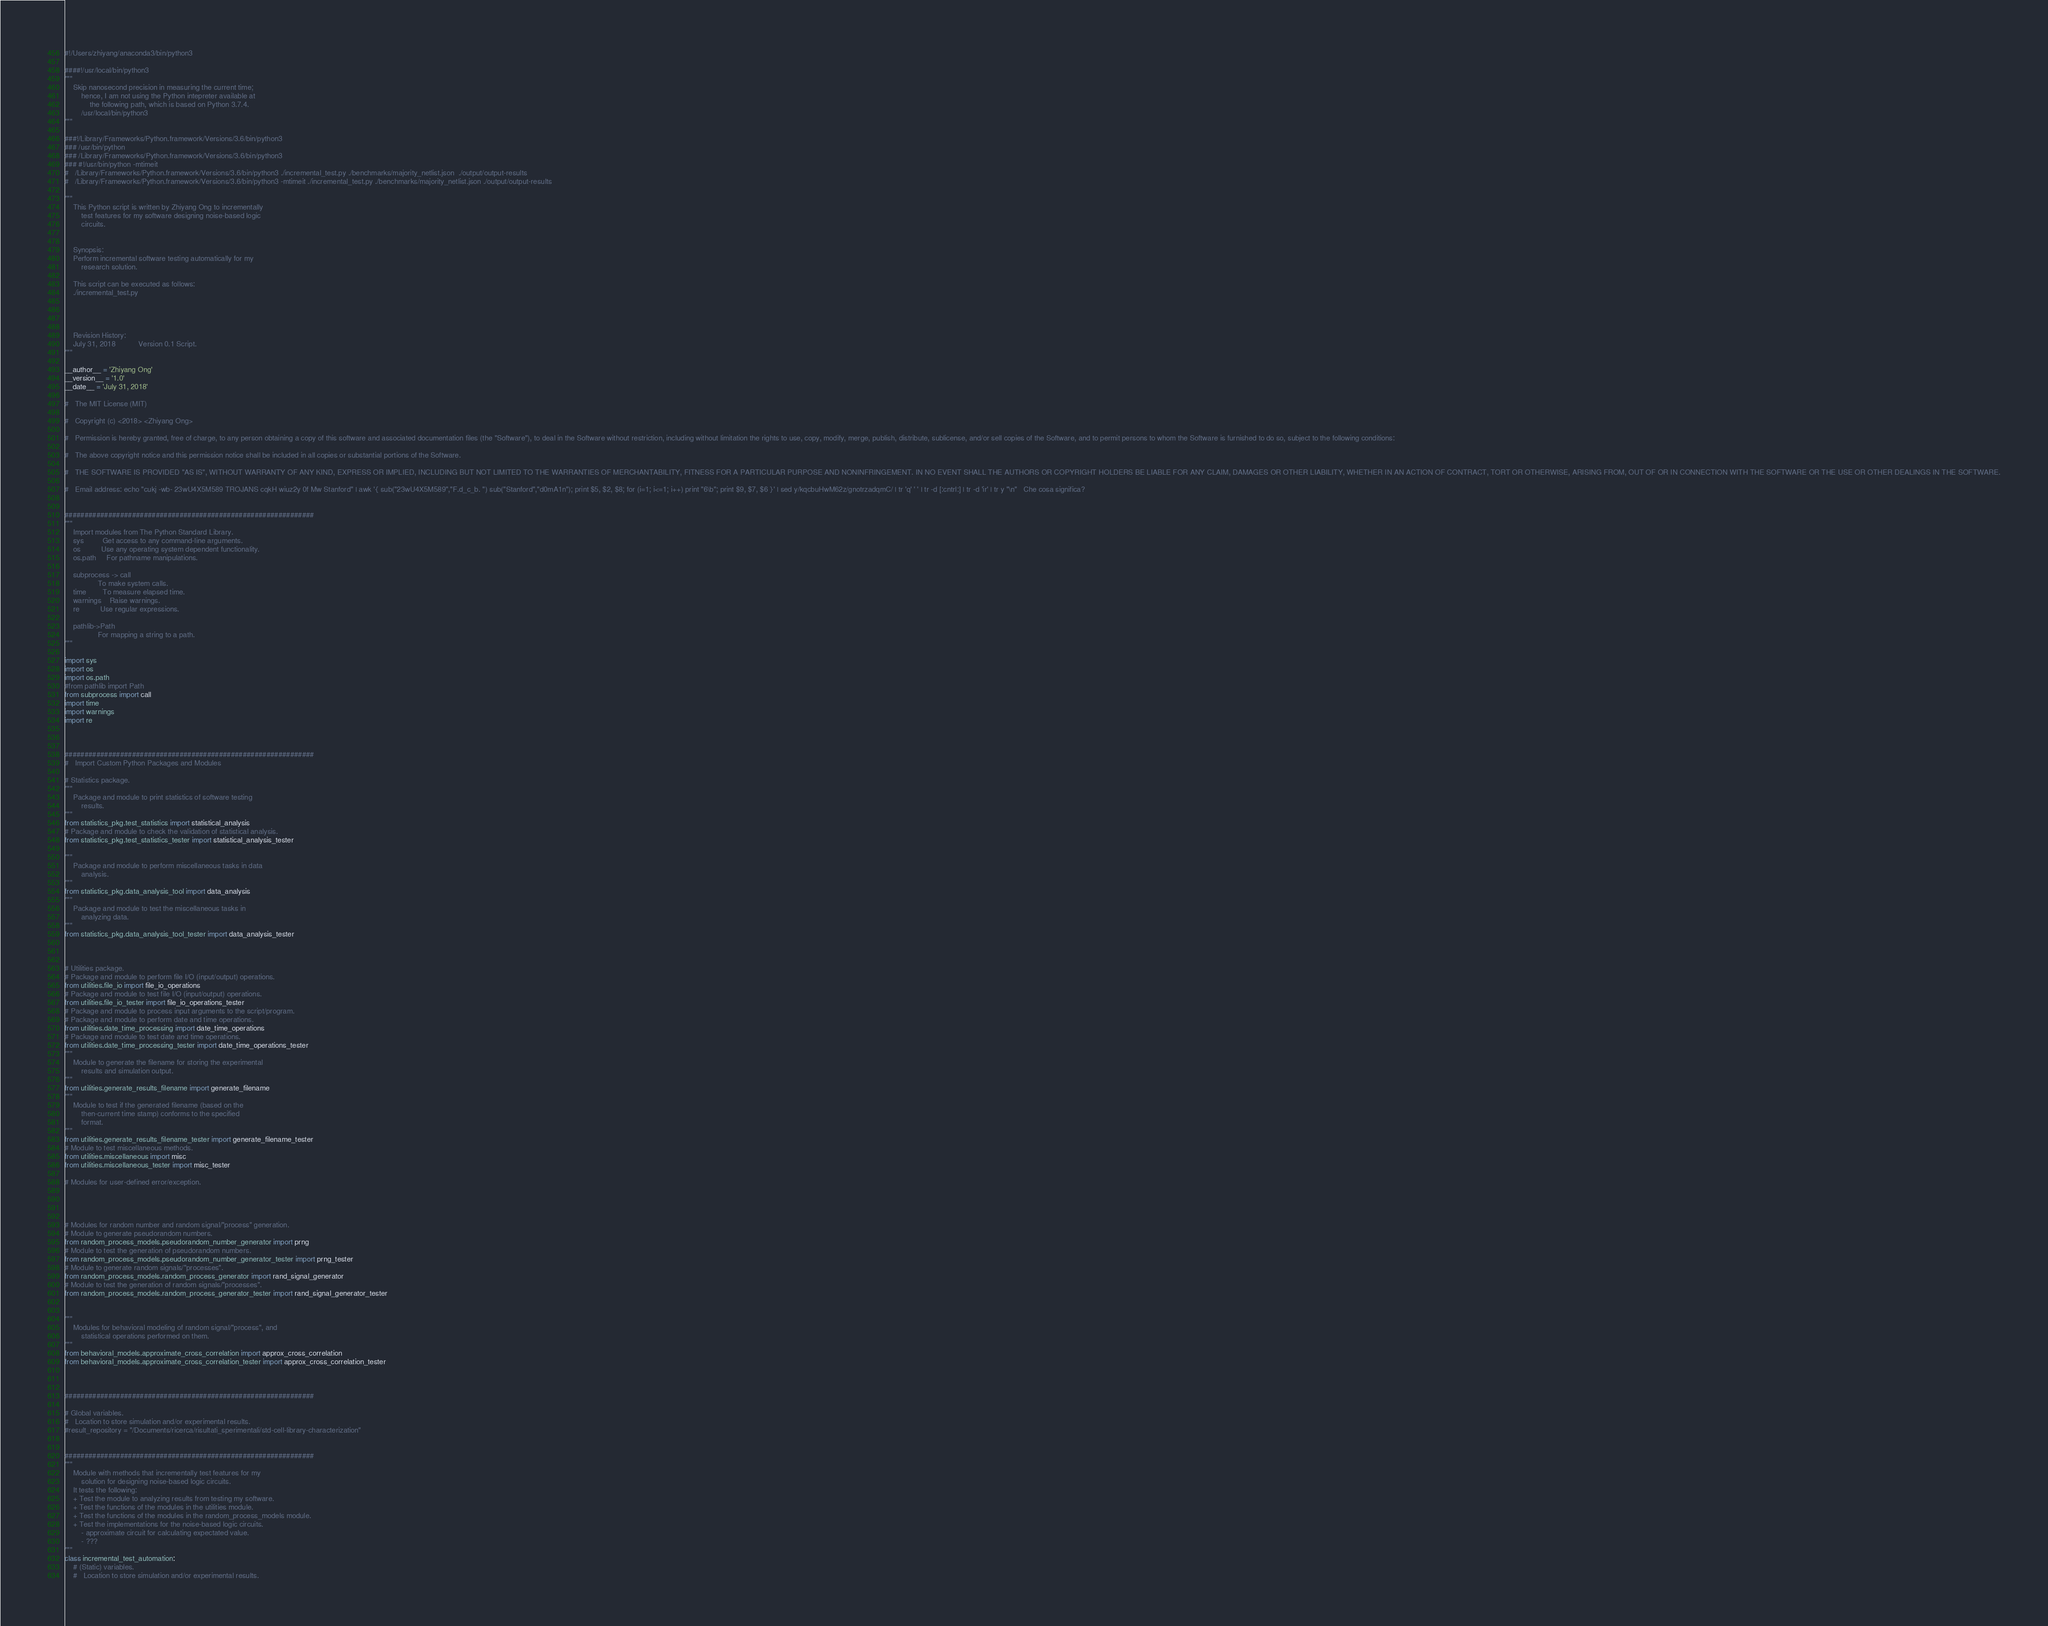Convert code to text. <code><loc_0><loc_0><loc_500><loc_500><_Python_>#!/Users/zhiyang/anaconda3/bin/python3 

####!/usr/local/bin/python3
"""
	Skip nanosecond precision in measuring the current time;
		hence, I am not using the Python intepreter available at
			the following path, which is based on Python 3.7.4.
		/usr/local/bin/python3
"""

###!/Library/Frameworks/Python.framework/Versions/3.6/bin/python3
###	/usr/bin/python
###	/Library/Frameworks/Python.framework/Versions/3.6/bin/python3
###	#!/usr/bin/python -mtimeit
#	/Library/Frameworks/Python.framework/Versions/3.6/bin/python3 ./incremental_test.py ./benchmarks/majority_netlist.json	./output/output-results
#	/Library/Frameworks/Python.framework/Versions/3.6/bin/python3 -mtimeit ./incremental_test.py ./benchmarks/majority_netlist.json	./output/output-results

"""
	This Python script is written by Zhiyang Ong to incrementally
		test features for my software designing noise-based logic
		circuits.


	Synopsis:
	Perform incremental software testing automatically for my
		research solution.

	This script can be executed as follows:
	./incremental_test.py




	Revision History:
	July 31, 2018			Version 0.1	Script.
"""

__author__ = 'Zhiyang Ong'
__version__ = '1.0'
__date__ = 'July 31, 2018'

#	The MIT License (MIT)

#	Copyright (c) <2018> <Zhiyang Ong>

#	Permission is hereby granted, free of charge, to any person obtaining a copy of this software and associated documentation files (the "Software"), to deal in the Software without restriction, including without limitation the rights to use, copy, modify, merge, publish, distribute, sublicense, and/or sell copies of the Software, and to permit persons to whom the Software is furnished to do so, subject to the following conditions:

#	The above copyright notice and this permission notice shall be included in all copies or substantial portions of the Software.

#	THE SOFTWARE IS PROVIDED "AS IS", WITHOUT WARRANTY OF ANY KIND, EXPRESS OR IMPLIED, INCLUDING BUT NOT LIMITED TO THE WARRANTIES OF MERCHANTABILITY, FITNESS FOR A PARTICULAR PURPOSE AND NONINFRINGEMENT. IN NO EVENT SHALL THE AUTHORS OR COPYRIGHT HOLDERS BE LIABLE FOR ANY CLAIM, DAMAGES OR OTHER LIABILITY, WHETHER IN AN ACTION OF CONTRACT, TORT OR OTHERWISE, ARISING FROM, OUT OF OR IN CONNECTION WITH THE SOFTWARE OR THE USE OR OTHER DEALINGS IN THE SOFTWARE.

#	Email address: echo "cukj -wb- 23wU4X5M589 TROJANS cqkH wiuz2y 0f Mw Stanford" | awk '{ sub("23wU4X5M589","F.d_c_b. ") sub("Stanford","d0mA1n"); print $5, $2, $8; for (i=1; i<=1; i++) print "6\b"; print $9, $7, $6 }' | sed y/kqcbuHwM62z/gnotrzadqmC/ | tr 'q' ' ' | tr -d [:cntrl:] | tr -d 'ir' | tr y "\n"	Che cosa significa?


###############################################################
"""
	Import modules from The Python Standard Library.
	sys			Get access to any command-line arguments.
	os			Use any operating system dependent functionality.
	os.path		For pathname manipulations.

	subprocess -> call
				To make system calls.
	time		To measure elapsed time.
	warnings	Raise warnings.
	re			Use regular expressions.

	pathlib->Path
				For mapping a string to a path.
"""

import sys
import os
import os.path
#from pathlib import Path
from subprocess import call
import time
import warnings
import re



###############################################################
#	Import Custom Python Packages and Modules

# Statistics package.
"""
	Package and module to print statistics of software testing
		results.
"""
from statistics_pkg.test_statistics import statistical_analysis
# Package and module to check the validation of statistical analysis.
from statistics_pkg.test_statistics_tester import statistical_analysis_tester

"""
	Package and module to perform miscellaneous tasks in data
		analysis.
"""
from statistics_pkg.data_analysis_tool import data_analysis
"""
	Package and module to test the miscellaneous tasks in
		analyzing data. 
"""
from statistics_pkg.data_analysis_tool_tester import data_analysis_tester



# Utilities package.
# Package and module to perform file I/O (input/output) operations.
from utilities.file_io import file_io_operations
# Package and module to test file I/O (input/output) operations.
from utilities.file_io_tester import file_io_operations_tester
# Package and module to process input arguments to the script/program.
# Package and module to perform date and time operations.
from utilities.date_time_processing import date_time_operations
# Package and module to test date and time operations.
from utilities.date_time_processing_tester import date_time_operations_tester
"""
	Module to generate the filename for storing the experimental
		results and simulation output.
"""
from utilities.generate_results_filename import generate_filename
"""
	Module to test if the generated filename (based on the
		then-current time stamp) conforms to the specified
		format.
"""
from utilities.generate_results_filename_tester import generate_filename_tester
# Module to test miscellaneous methods.
from utilities.miscellaneous import misc
from utilities.miscellaneous_tester import misc_tester

# Modules for user-defined error/exception.




# Modules for random number and random signal/"process" generation.
# Module to generate pseudorandom numbers.
from random_process_models.pseudorandom_number_generator import prng
# Module to test the generation of pseudorandom numbers.
from random_process_models.pseudorandom_number_generator_tester import prng_tester
# Module to generate random signals/"processes".
from random_process_models.random_process_generator import rand_signal_generator
# Module to test the generation of random signals/"processes".
from random_process_models.random_process_generator_tester import rand_signal_generator_tester


"""
	Modules for behavioral modeling of random signal/"process", and
		statistical operations performed on them.
"""
from behavioral_models.approximate_cross_correlation import approx_cross_correlation
from behavioral_models.approximate_cross_correlation_tester import approx_cross_correlation_tester



###############################################################

# Global variables.
#	Location to store simulation and/or experimental results.
#result_repository = "/Documents/ricerca/risultati_sperimentali/std-cell-library-characterization"


###############################################################
"""
	Module with methods that incrementally test features for my
		solution for designing noise-based logic circuits.
	It tests the following:
	+ Test the module to analyzing results from testing my software.
	+ Test the functions of the modules in the utilities module.
	+ Test the functions of the modules in the random_process_models module.
	+ Test the implementations for the noise-based logic circuits.
		- approximate circuit for calculating expectated value.
		- ???
"""
class incremental_test_automation:
	# (Static) variables.
	#	Location to store simulation and/or experimental results.</code> 